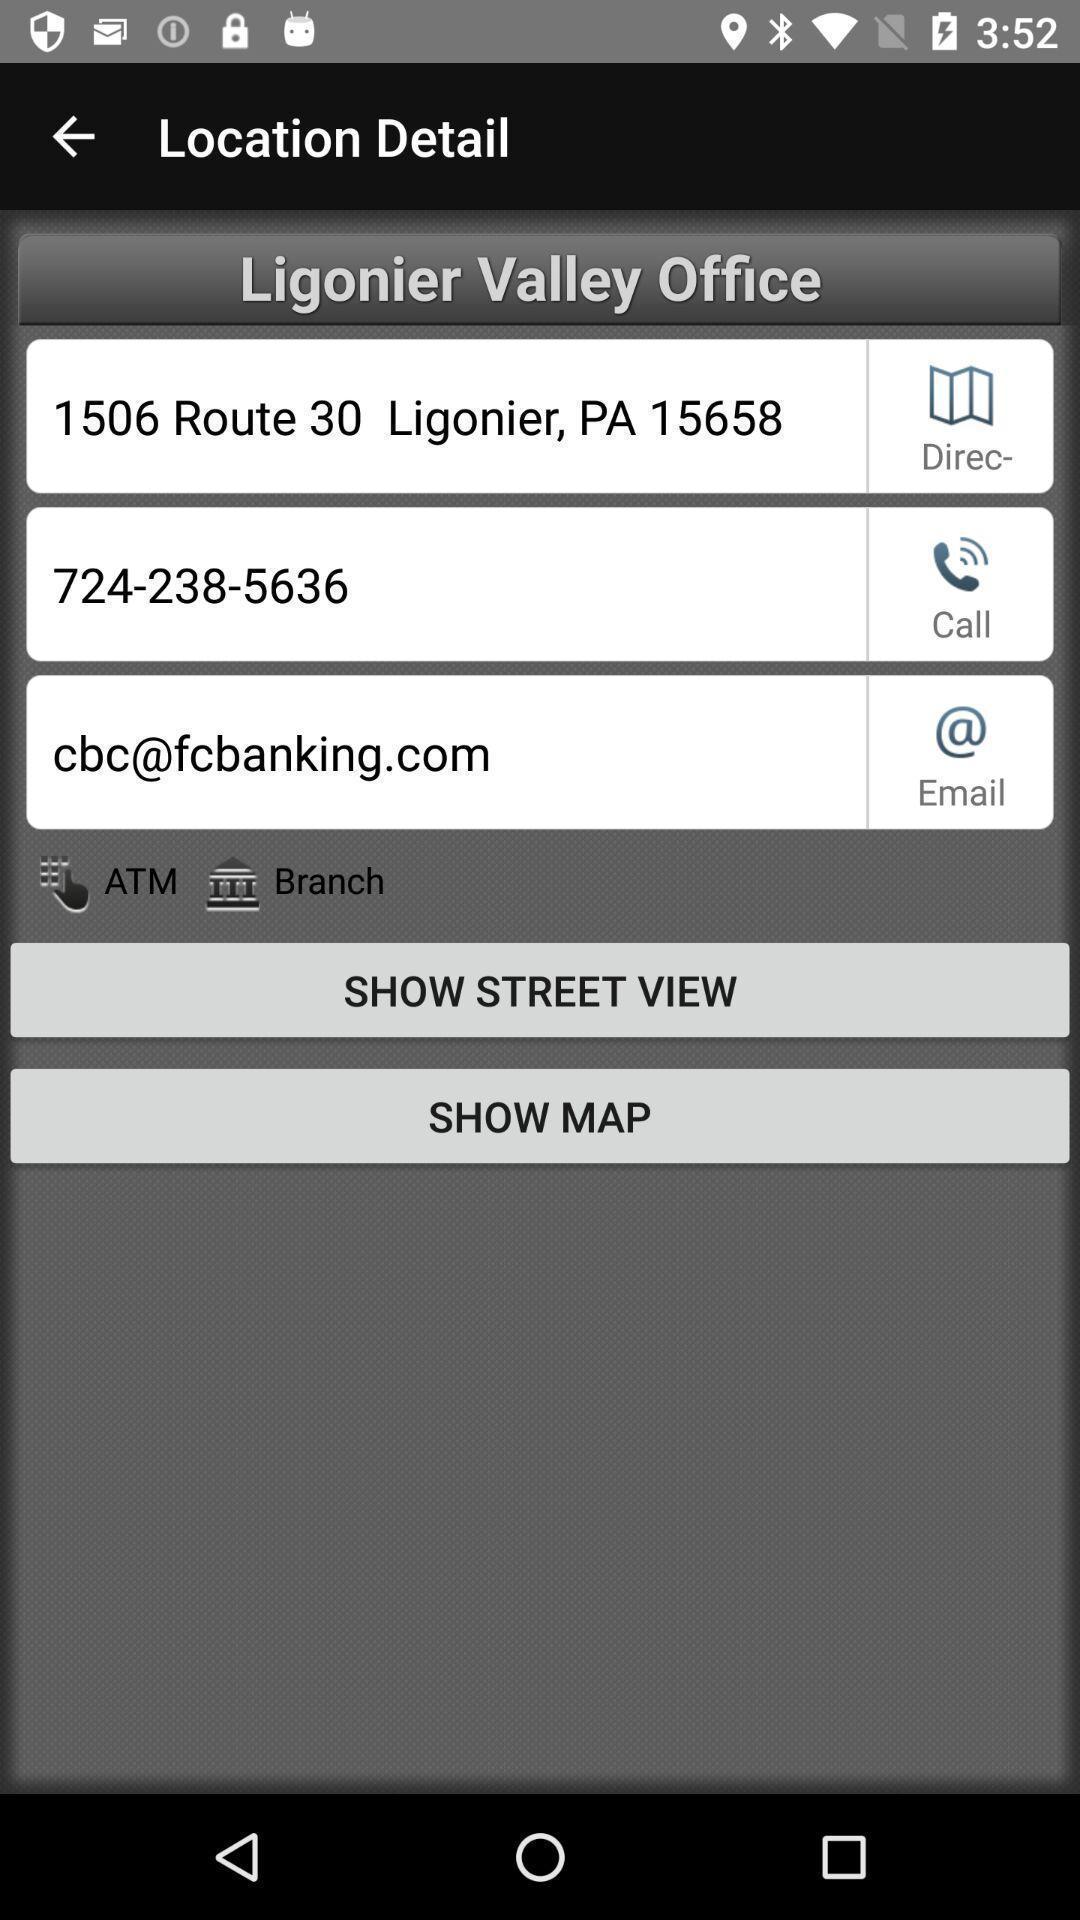Describe the key features of this screenshot. Page shows location detail with few options in service application. 